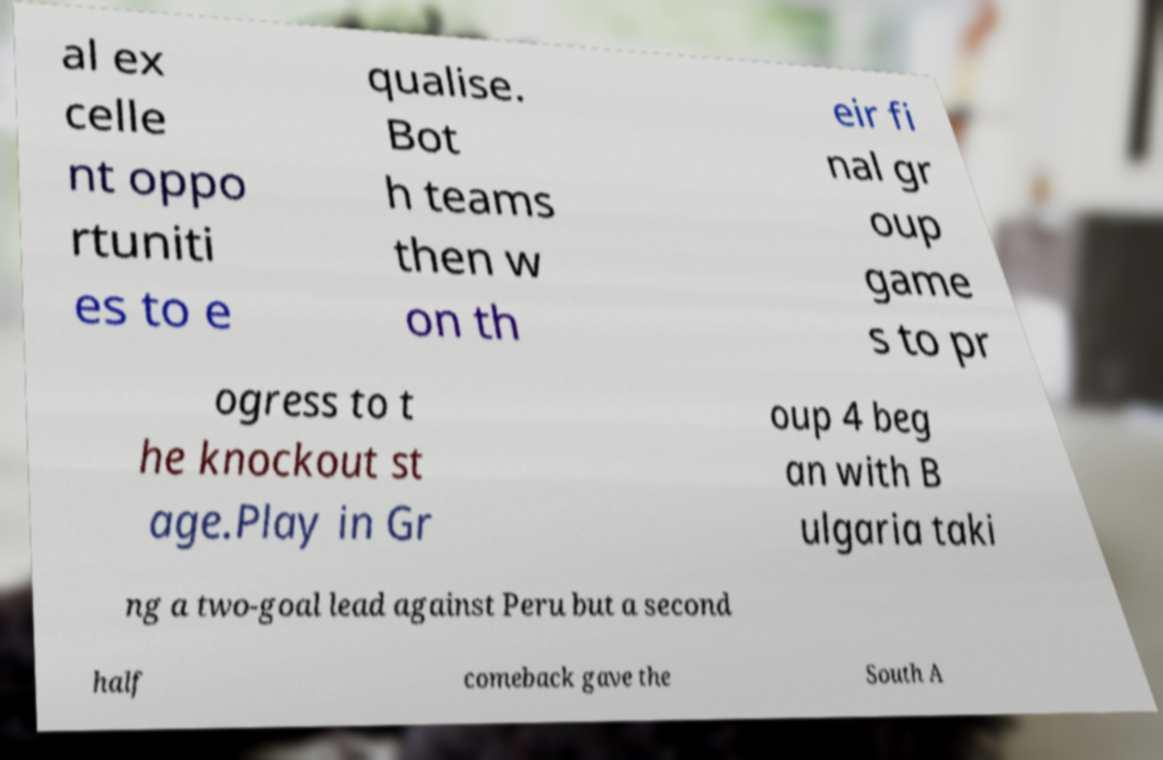What messages or text are displayed in this image? I need them in a readable, typed format. al ex celle nt oppo rtuniti es to e qualise. Bot h teams then w on th eir fi nal gr oup game s to pr ogress to t he knockout st age.Play in Gr oup 4 beg an with B ulgaria taki ng a two-goal lead against Peru but a second half comeback gave the South A 